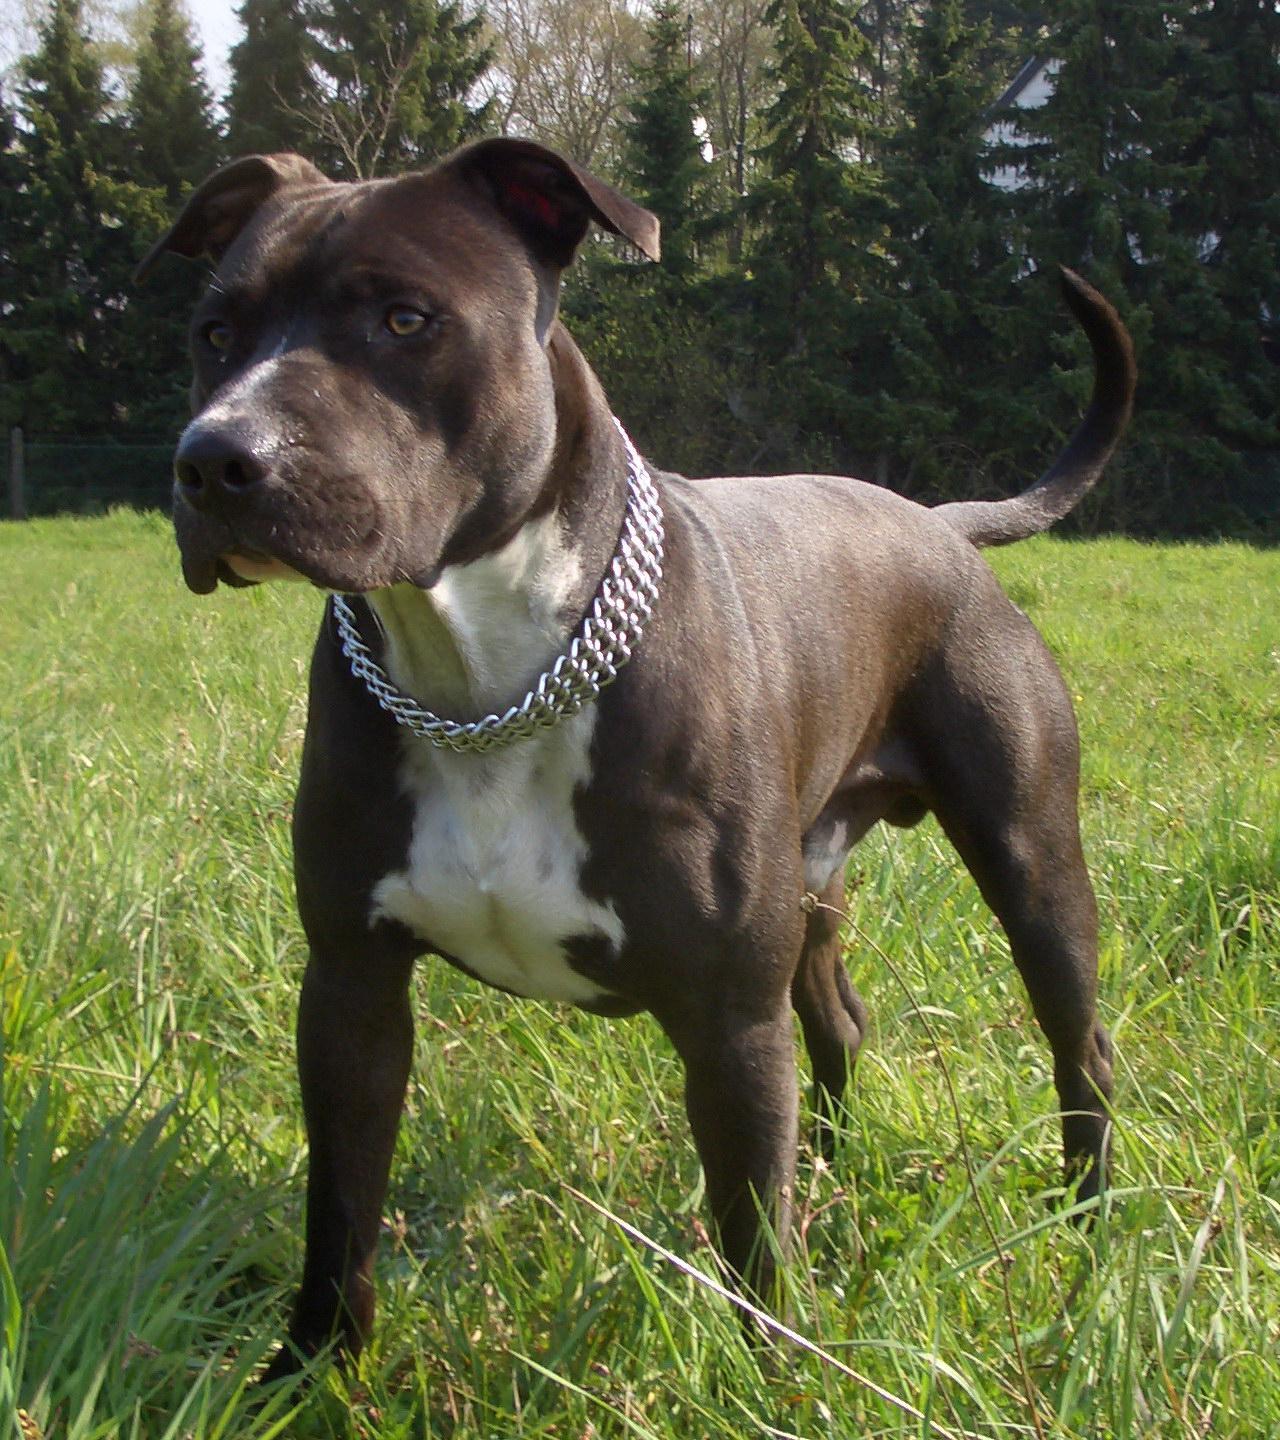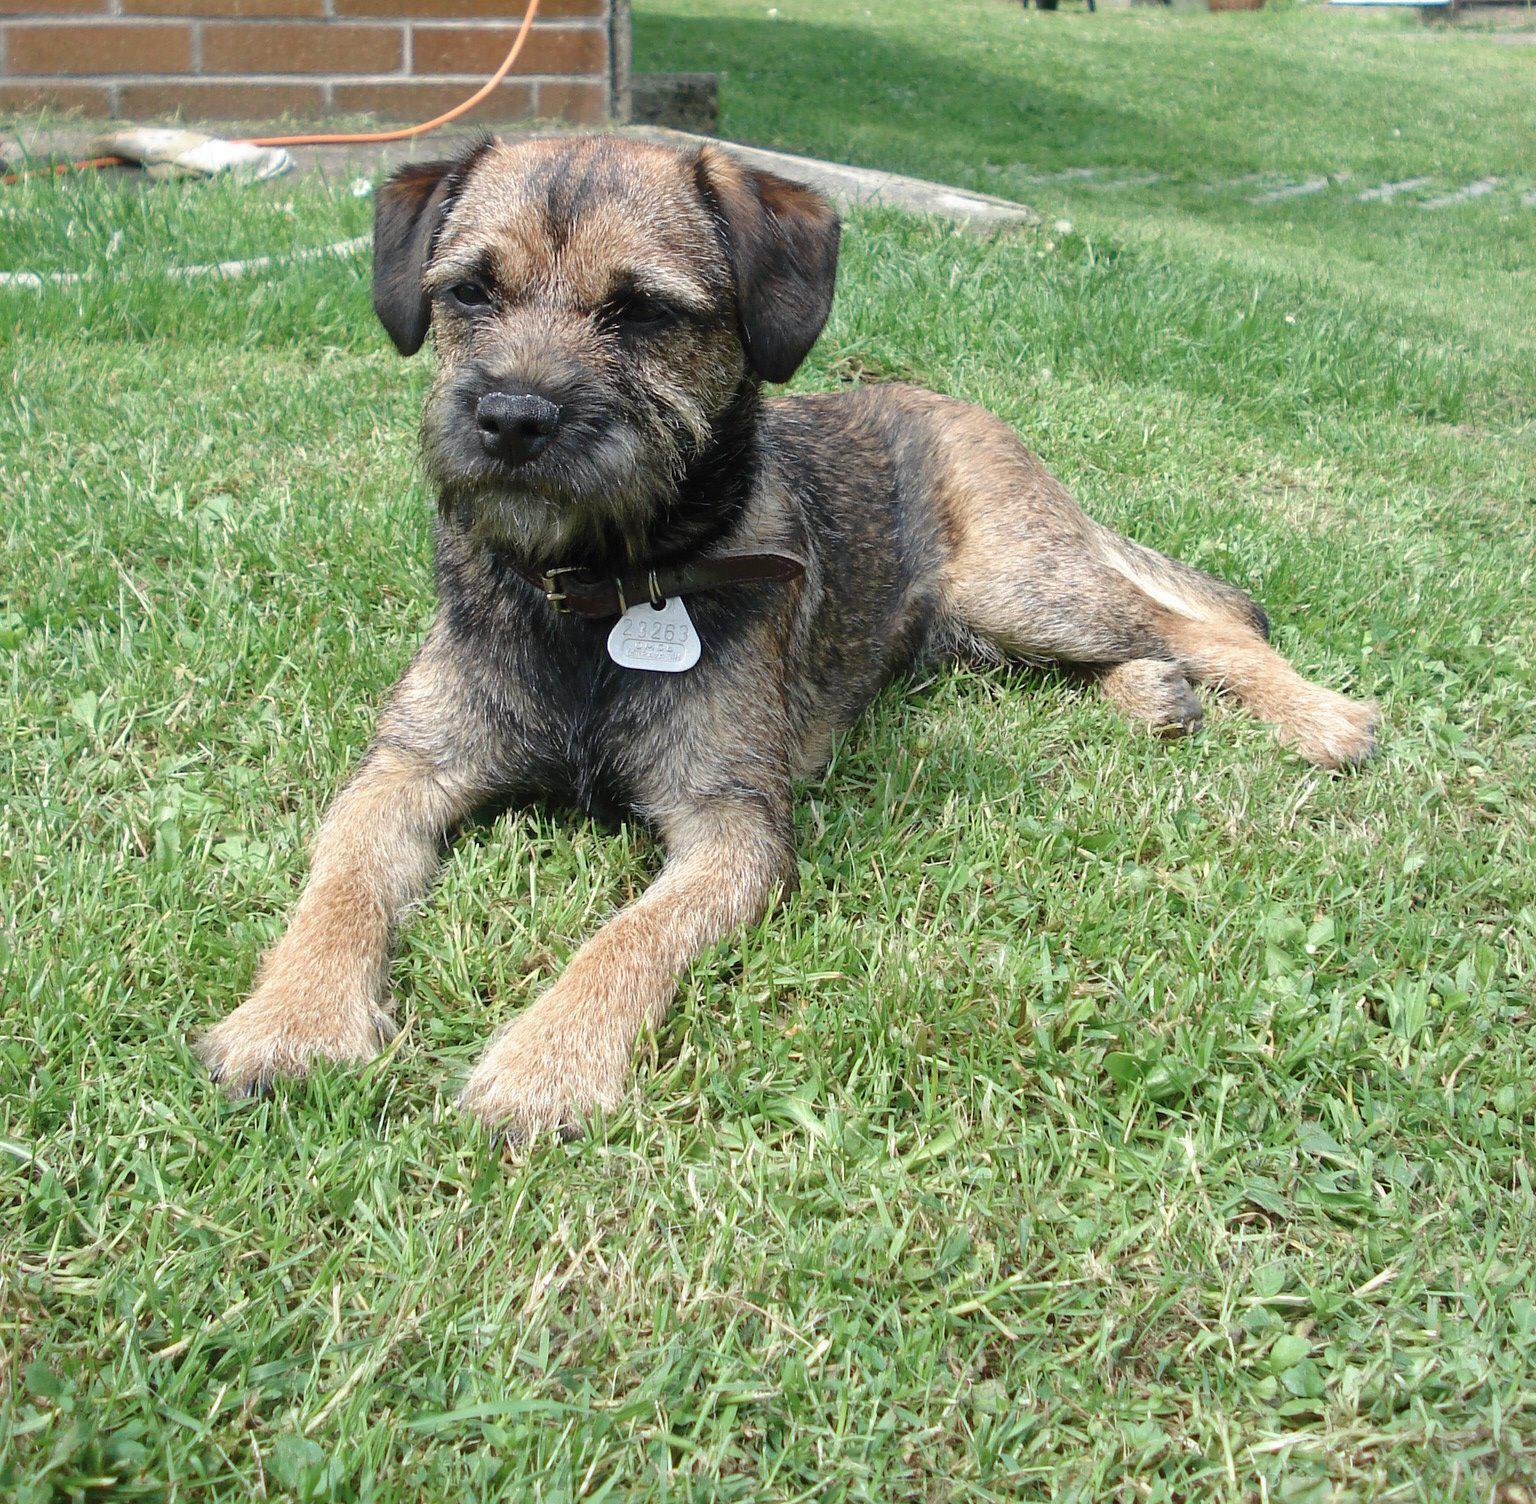The first image is the image on the left, the second image is the image on the right. For the images shown, is this caption "a dog is carrying a dead animal in it's mouth" true? Answer yes or no. No. The first image is the image on the left, the second image is the image on the right. Examine the images to the left and right. Is the description "One of the pictures has a dog carrying another animal in its mouth." accurate? Answer yes or no. No. 